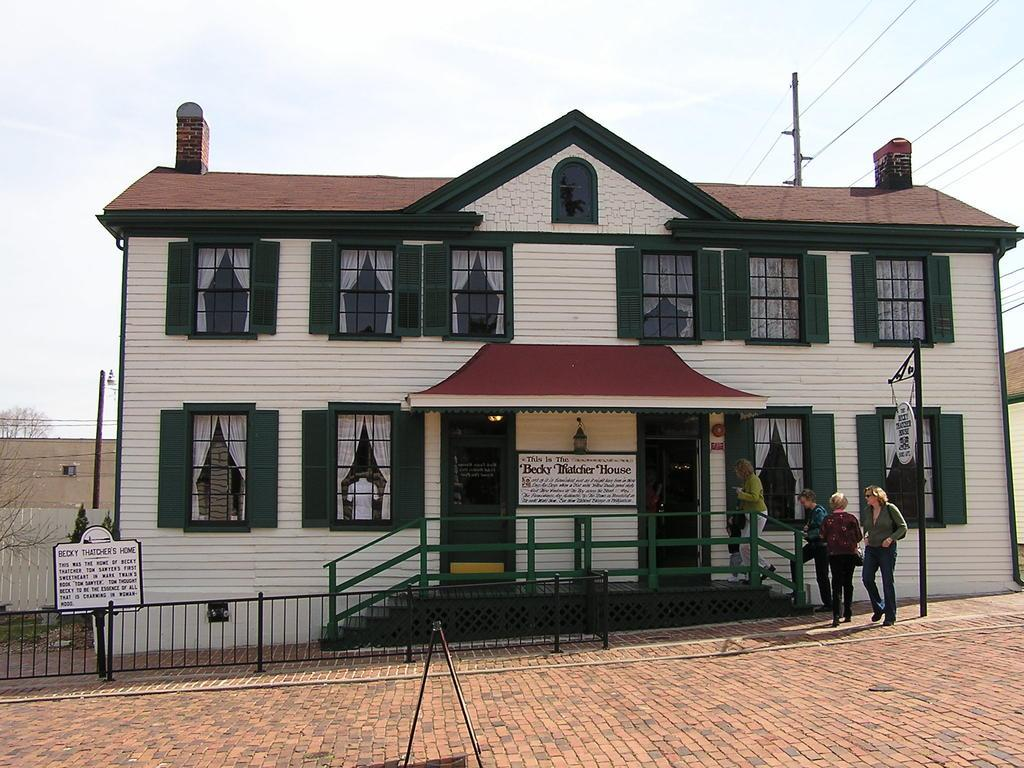How many persons are in the foreground of the image? There are five persons in the foreground of the image. What objects or structures are present in the foreground of the image? There is a board, a fence, buildings, and windows in the foreground of the image. What can be seen in the background of the image? There is a pole, wires, and the sky visible in the background of the image. What might be inferred about the weather on the day the image was taken? The image was likely taken on a sunny day, as the sky is visible and there are no clouds or rain visible. What type of suit is the person in the image wearing? There is no person wearing a suit in the image. Can you tell me how many horses are visible in the image? There are no horses present in the image. 